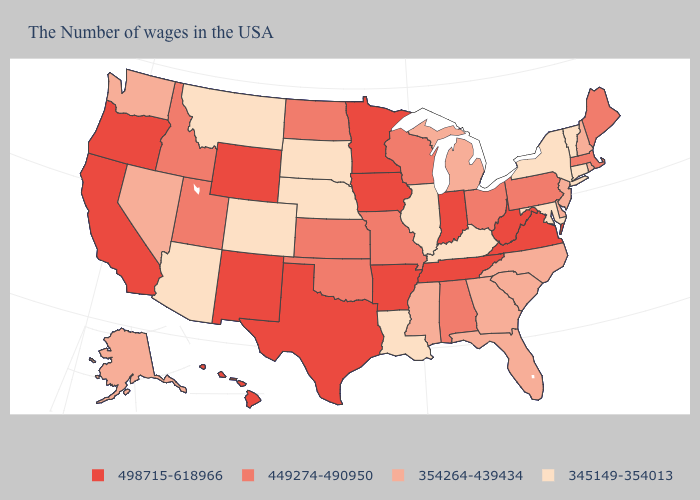Name the states that have a value in the range 449274-490950?
Short answer required. Maine, Massachusetts, Pennsylvania, Ohio, Alabama, Wisconsin, Missouri, Kansas, Oklahoma, North Dakota, Utah, Idaho. Name the states that have a value in the range 345149-354013?
Be succinct. Vermont, Connecticut, New York, Maryland, Kentucky, Illinois, Louisiana, Nebraska, South Dakota, Colorado, Montana, Arizona. What is the value of Michigan?
Be succinct. 354264-439434. Name the states that have a value in the range 498715-618966?
Keep it brief. Virginia, West Virginia, Indiana, Tennessee, Arkansas, Minnesota, Iowa, Texas, Wyoming, New Mexico, California, Oregon, Hawaii. Name the states that have a value in the range 345149-354013?
Write a very short answer. Vermont, Connecticut, New York, Maryland, Kentucky, Illinois, Louisiana, Nebraska, South Dakota, Colorado, Montana, Arizona. Among the states that border Texas , does Louisiana have the highest value?
Be succinct. No. Does Iowa have a higher value than Wyoming?
Quick response, please. No. What is the lowest value in states that border New Mexico?
Answer briefly. 345149-354013. Does Louisiana have a lower value than Arizona?
Give a very brief answer. No. Does Virginia have the lowest value in the South?
Write a very short answer. No. Name the states that have a value in the range 498715-618966?
Give a very brief answer. Virginia, West Virginia, Indiana, Tennessee, Arkansas, Minnesota, Iowa, Texas, Wyoming, New Mexico, California, Oregon, Hawaii. Does Pennsylvania have a lower value than Nebraska?
Quick response, please. No. Is the legend a continuous bar?
Give a very brief answer. No. What is the lowest value in the USA?
Concise answer only. 345149-354013. What is the lowest value in the USA?
Short answer required. 345149-354013. 